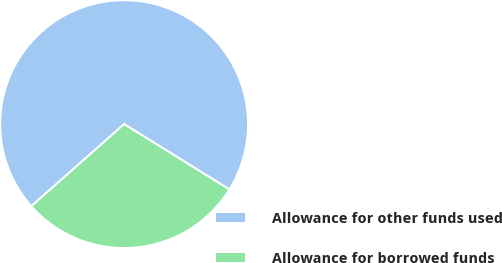Convert chart. <chart><loc_0><loc_0><loc_500><loc_500><pie_chart><fcel>Allowance for other funds used<fcel>Allowance for borrowed funds<nl><fcel>70.37%<fcel>29.63%<nl></chart> 